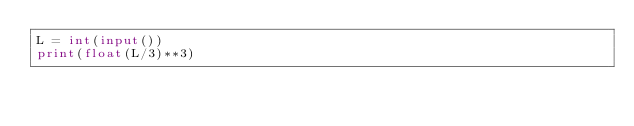<code> <loc_0><loc_0><loc_500><loc_500><_Python_>L = int(input())
print(float(L/3)**3)
</code> 